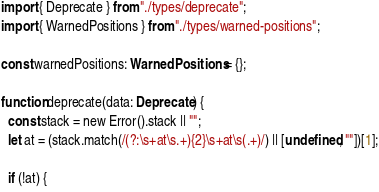<code> <loc_0><loc_0><loc_500><loc_500><_TypeScript_>import { Deprecate } from "./types/deprecate";
import { WarnedPositions } from "./types/warned-positions";

const warnedPositions: WarnedPositions = {};

function deprecate(data: Deprecate) {
  const stack = new Error().stack || "";
  let at = (stack.match(/(?:\s+at\s.+){2}\s+at\s(.+)/) || [undefined, ""])[1];

  if (!at) {</code> 